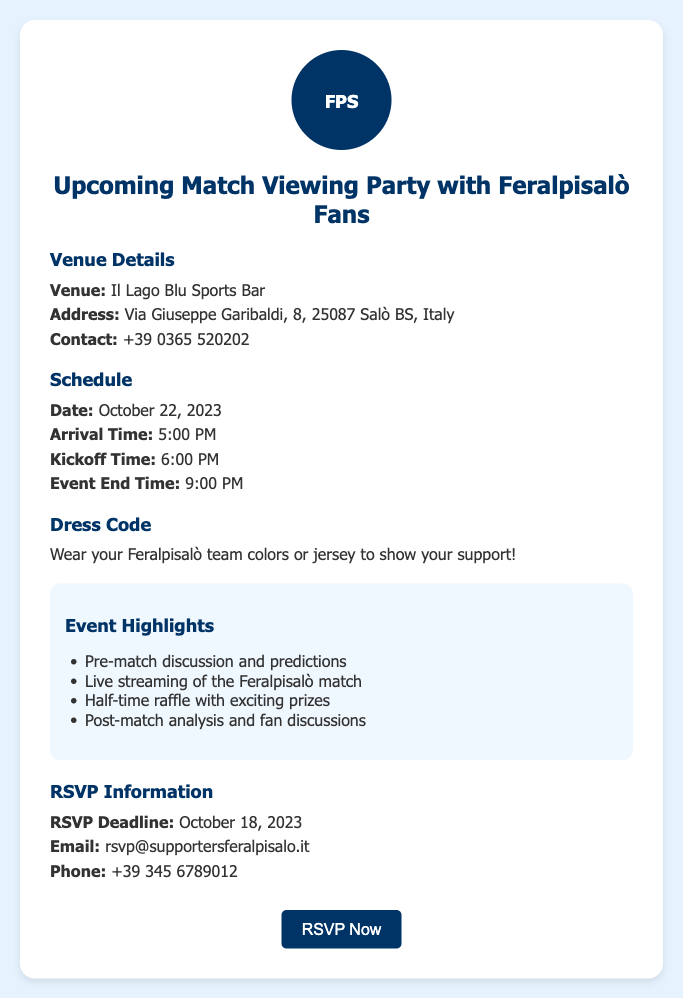What is the venue for the viewing party? The venue is specified in the document under Venue Details.
Answer: Il Lago Blu Sports Bar What is the address of the venue? The address is mentioned right after the venue name in Venue Details.
Answer: Via Giuseppe Garibaldi, 8, 25087 Salò BS, Italy What is the kick-off time for the match? The kick-off time is listed in the Schedule section.
Answer: 6:00 PM When is the RSVP deadline? The RSVP deadline is clearly stated in the RSVP Information section.
Answer: October 18, 2023 What should attendees wear? The dress code is outlined in the Dress Code section of the document.
Answer: Feralpisalò team colors or jersey What time does the event end? The end time of the event is detailed in the Schedule section.
Answer: 9:00 PM What is the contact number for the venue? The contact number is provided in the Venue Details section.
Answer: +39 0365 520202 What is one highlight of the event? The highlights are listed under Event Highlights in the document.
Answer: Half-time raffle with exciting prizes What is the email to RSVP? The email for RSVP is mentioned in the RSVP Information section.
Answer: rsvp@supportersferalpisalo.it 